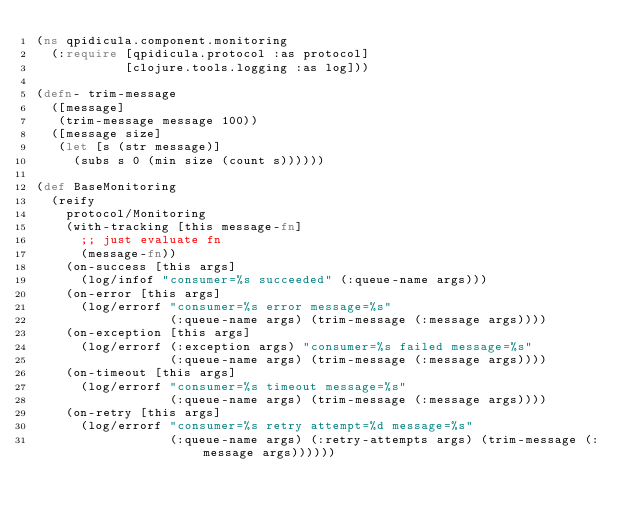Convert code to text. <code><loc_0><loc_0><loc_500><loc_500><_Clojure_>(ns qpidicula.component.monitoring
  (:require [qpidicula.protocol :as protocol]
            [clojure.tools.logging :as log]))

(defn- trim-message
  ([message]
   (trim-message message 100))
  ([message size]
   (let [s (str message)]
     (subs s 0 (min size (count s))))))

(def BaseMonitoring
  (reify
    protocol/Monitoring
    (with-tracking [this message-fn]
      ;; just evaluate fn
      (message-fn))
    (on-success [this args]
      (log/infof "consumer=%s succeeded" (:queue-name args)))
    (on-error [this args]
      (log/errorf "consumer=%s error message=%s"
                  (:queue-name args) (trim-message (:message args))))
    (on-exception [this args]
      (log/errorf (:exception args) "consumer=%s failed message=%s"
                  (:queue-name args) (trim-message (:message args))))
    (on-timeout [this args]
      (log/errorf "consumer=%s timeout message=%s"
                  (:queue-name args) (trim-message (:message args))))
    (on-retry [this args]
      (log/errorf "consumer=%s retry attempt=%d message=%s"
                  (:queue-name args) (:retry-attempts args) (trim-message (:message args))))))</code> 